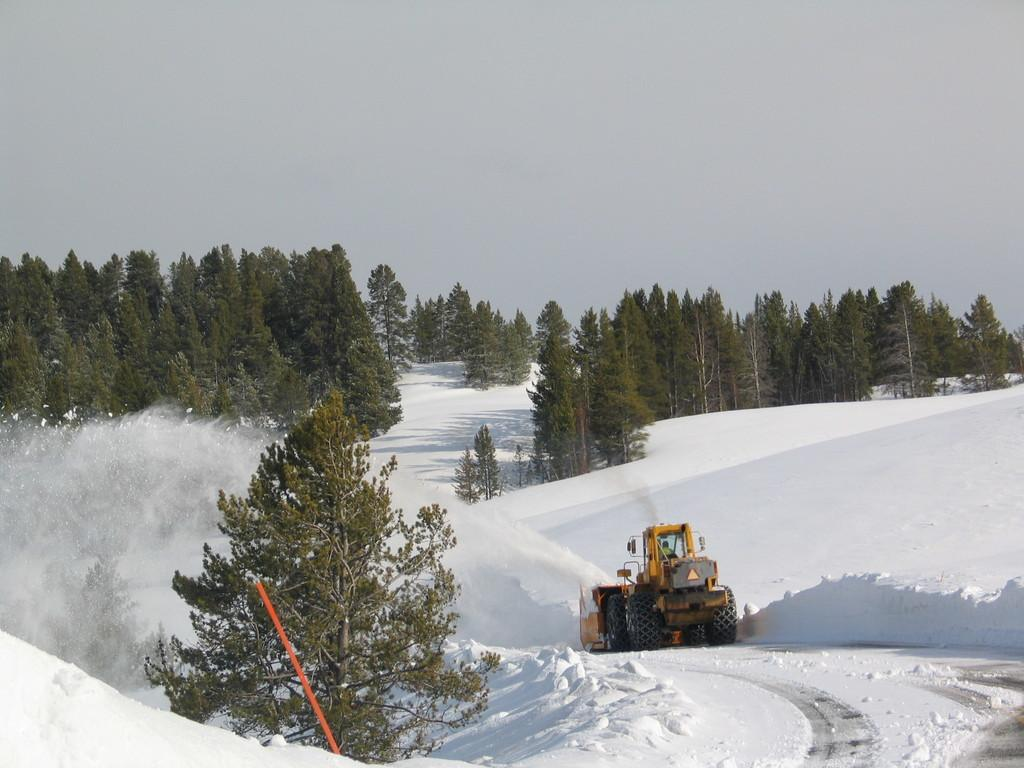What is the main subject of the image? There is a vehicle in the image. What is the condition of the ground around the vehicle? The vehicle is in the snow. What can be seen on the left side of the image? There is a pole on the left side of the image. What is visible in the background of the image? There are trees in the background of the image. How many questions can be seen in the image? There are no questions visible in the image; it features a vehicle in the snow with a pole on the left side and trees in the background. 